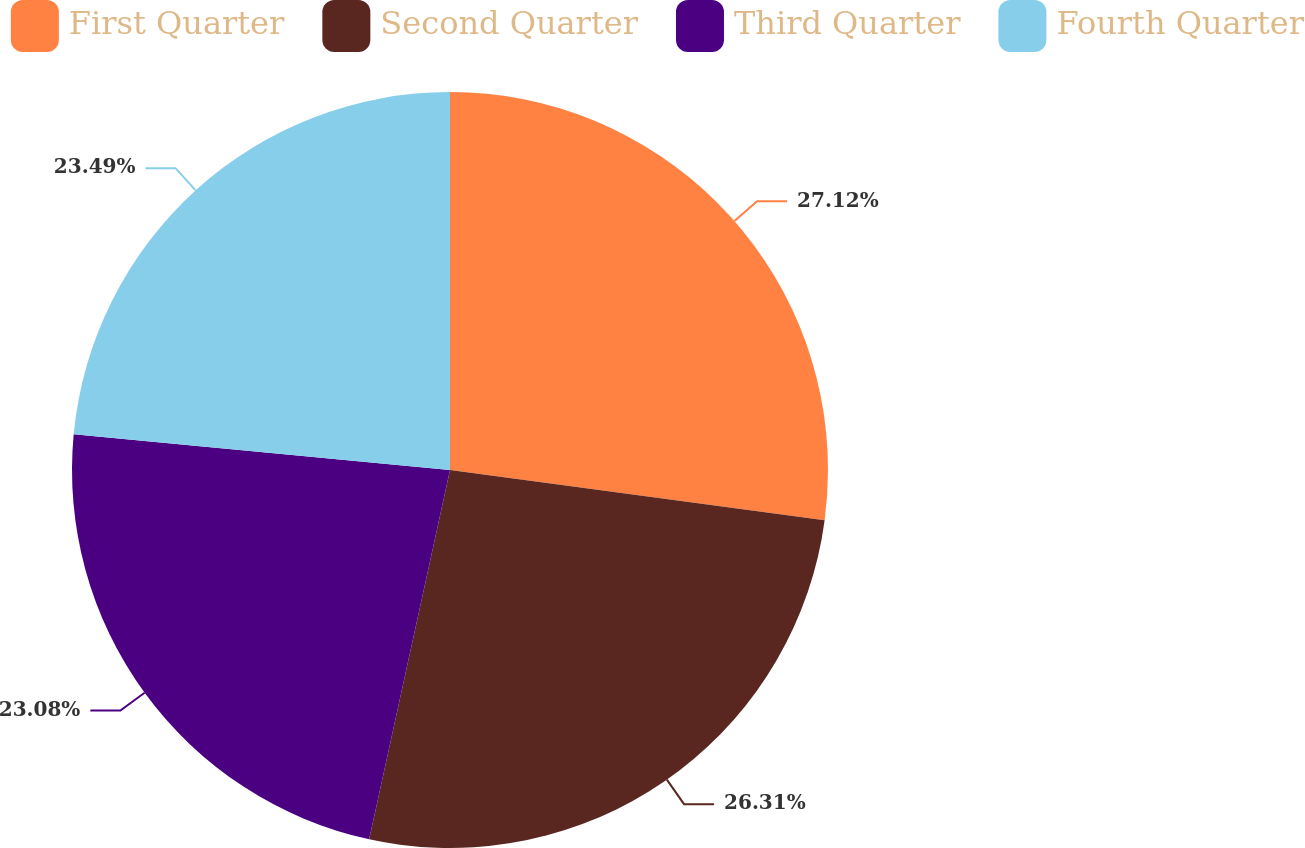<chart> <loc_0><loc_0><loc_500><loc_500><pie_chart><fcel>First Quarter<fcel>Second Quarter<fcel>Third Quarter<fcel>Fourth Quarter<nl><fcel>27.12%<fcel>26.31%<fcel>23.08%<fcel>23.49%<nl></chart> 